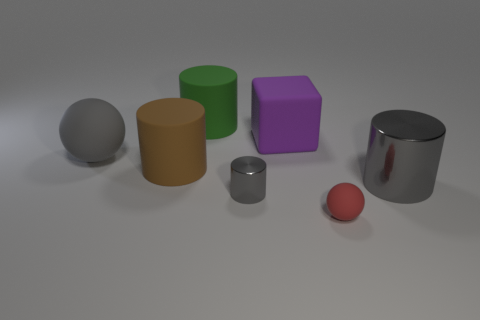How many other objects are the same size as the purple matte thing?
Make the answer very short. 4. Are there fewer big cyan matte spheres than gray cylinders?
Offer a very short reply. Yes. The purple matte object is what shape?
Give a very brief answer. Cube. There is a small object in front of the small gray cylinder; is it the same color as the tiny cylinder?
Provide a succinct answer. No. The rubber object that is both on the left side of the green rubber object and behind the brown cylinder has what shape?
Your answer should be very brief. Sphere. What color is the matte object that is in front of the small metal thing?
Provide a succinct answer. Red. Is there any other thing that has the same color as the big matte cube?
Your response must be concise. No. Do the purple rubber block and the gray rubber sphere have the same size?
Offer a very short reply. Yes. What is the size of the matte thing that is behind the small metallic cylinder and right of the tiny cylinder?
Your response must be concise. Large. What number of gray things are made of the same material as the red sphere?
Provide a short and direct response. 1. 